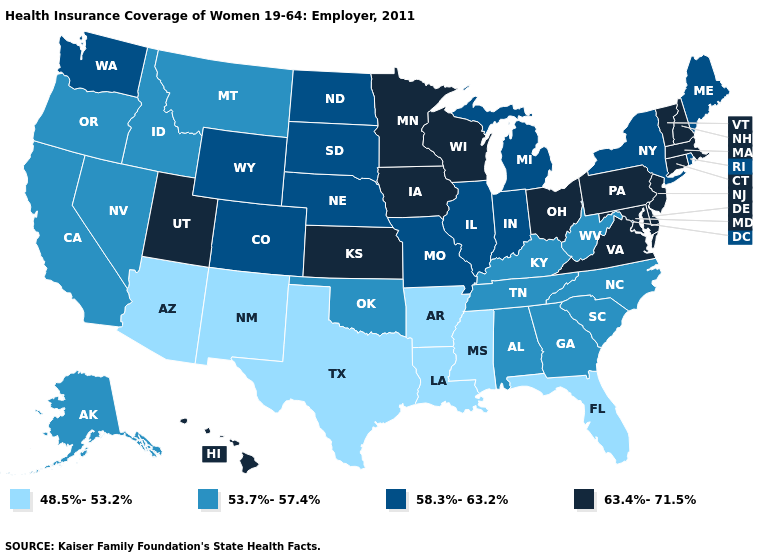Among the states that border Ohio , does Pennsylvania have the highest value?
Keep it brief. Yes. What is the value of Nebraska?
Be succinct. 58.3%-63.2%. Does North Dakota have the lowest value in the MidWest?
Be succinct. Yes. Name the states that have a value in the range 53.7%-57.4%?
Quick response, please. Alabama, Alaska, California, Georgia, Idaho, Kentucky, Montana, Nevada, North Carolina, Oklahoma, Oregon, South Carolina, Tennessee, West Virginia. Does the map have missing data?
Give a very brief answer. No. What is the value of Montana?
Quick response, please. 53.7%-57.4%. What is the lowest value in states that border North Carolina?
Keep it brief. 53.7%-57.4%. Name the states that have a value in the range 63.4%-71.5%?
Answer briefly. Connecticut, Delaware, Hawaii, Iowa, Kansas, Maryland, Massachusetts, Minnesota, New Hampshire, New Jersey, Ohio, Pennsylvania, Utah, Vermont, Virginia, Wisconsin. What is the highest value in states that border Connecticut?
Short answer required. 63.4%-71.5%. What is the lowest value in the MidWest?
Be succinct. 58.3%-63.2%. Among the states that border New Jersey , does Delaware have the highest value?
Keep it brief. Yes. Name the states that have a value in the range 53.7%-57.4%?
Write a very short answer. Alabama, Alaska, California, Georgia, Idaho, Kentucky, Montana, Nevada, North Carolina, Oklahoma, Oregon, South Carolina, Tennessee, West Virginia. What is the value of Hawaii?
Write a very short answer. 63.4%-71.5%. What is the value of Arkansas?
Quick response, please. 48.5%-53.2%. Which states have the highest value in the USA?
Keep it brief. Connecticut, Delaware, Hawaii, Iowa, Kansas, Maryland, Massachusetts, Minnesota, New Hampshire, New Jersey, Ohio, Pennsylvania, Utah, Vermont, Virginia, Wisconsin. 